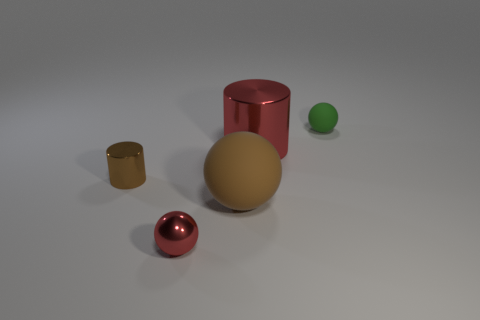Do the matte thing in front of the small green object and the red shiny thing on the right side of the shiny sphere have the same shape?
Provide a succinct answer. No. There is a brown shiny thing that is the same size as the green ball; what shape is it?
Your answer should be compact. Cylinder. Do the red thing that is to the right of the brown matte object and the small ball that is in front of the green rubber ball have the same material?
Your answer should be very brief. Yes. Is there a tiny metal thing that is behind the small sphere in front of the tiny cylinder?
Provide a succinct answer. Yes. There is a small cylinder that is the same material as the tiny red object; what color is it?
Your answer should be very brief. Brown. Are there more red metallic spheres than small red rubber cylinders?
Offer a terse response. Yes. How many things are small balls that are in front of the big red shiny object or large metallic balls?
Keep it short and to the point. 1. Is there a green matte sphere of the same size as the red sphere?
Make the answer very short. Yes. Are there fewer large brown matte objects than tiny metallic objects?
Provide a short and direct response. Yes. How many blocks are either red objects or green matte objects?
Your response must be concise. 0. 